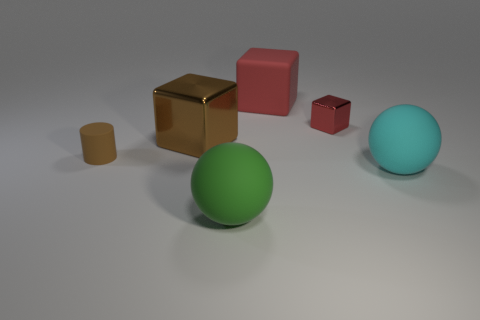How many things are cyan things or objects that are right of the large brown metallic cube?
Give a very brief answer. 4. Are there fewer tiny yellow matte objects than red shiny objects?
Offer a terse response. Yes. There is a sphere that is on the left side of the metallic thing that is behind the large metal thing that is to the left of the large cyan rubber sphere; what is its color?
Offer a terse response. Green. Does the green object have the same material as the tiny cylinder?
Your answer should be compact. Yes. What number of big green things are in front of the green sphere?
Your response must be concise. 0. The other red object that is the same shape as the tiny red object is what size?
Make the answer very short. Large. How many cyan things are matte cubes or small matte balls?
Keep it short and to the point. 0. How many large rubber objects are on the left side of the big matte sphere that is on the right side of the green rubber sphere?
Provide a short and direct response. 2. How many other things are the same shape as the brown metallic thing?
Provide a succinct answer. 2. What material is the other block that is the same color as the tiny shiny block?
Make the answer very short. Rubber. 